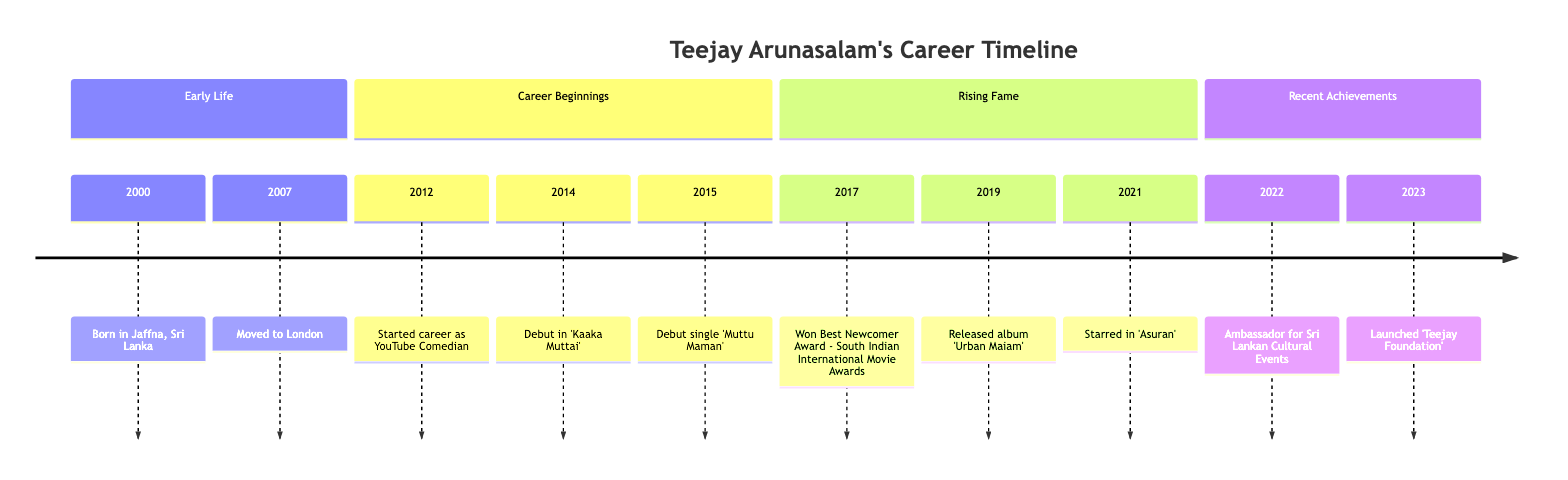What year was Teejay Arunasalam born? The timeline section "Early Life" shows the year 2000 as the date of birth for Teejay Arunasalam.
Answer: 2000 What was Teejay's debut single? The timeline indicates that his debut single, 'Muttu Maman', was released in 2015 under the section "Career Beginnings".
Answer: Muttu Maman Which award did Teejay win in 2017? The diagram indicates that in 2017, he won the Best Newcomer Award at the South Indian International Movie Awards, as shown in the "Rising Fame" section.
Answer: Best Newcomer Award In what year did Teejay launch the 'Teejay Foundation'? The timeline specifies that the 'Teejay Foundation' was launched in 2023, as stated in the "Recent Achievements" section.
Answer: 2023 How many albums did Teejay release from 2012 to 2021? Analyzing the timeline, 'Urban Maiam' was released in 2019. Thus, there is one album indicated during that period, from 2012 to 2021.
Answer: 1 What is the significance of 2022 in Teejay's career? The year 2022 is highlighted in the "Recent Achievements" section where it mentions his role as an ambassador for Sri Lankan Cultural Events, making it a notable year.
Answer: Ambassador How did Teejay’s career begin? According to the "Career Beginnings" section, Teejay started his career as a YouTube Comedian in 2012, indicating the nature of his initial career move.
Answer: YouTube Comedian What notable film did Teejay star in during 2021? The timeline shows that in the year 2021, Teejay starred in the film 'Asuran', making this a key milestone in that year.
Answer: Asuran What milestone occurred in 2019? The timeline indicates that in 2019, Teejay released his album 'Urban Maiam', marking a significant point in his career.
Answer: Urban Maiam 